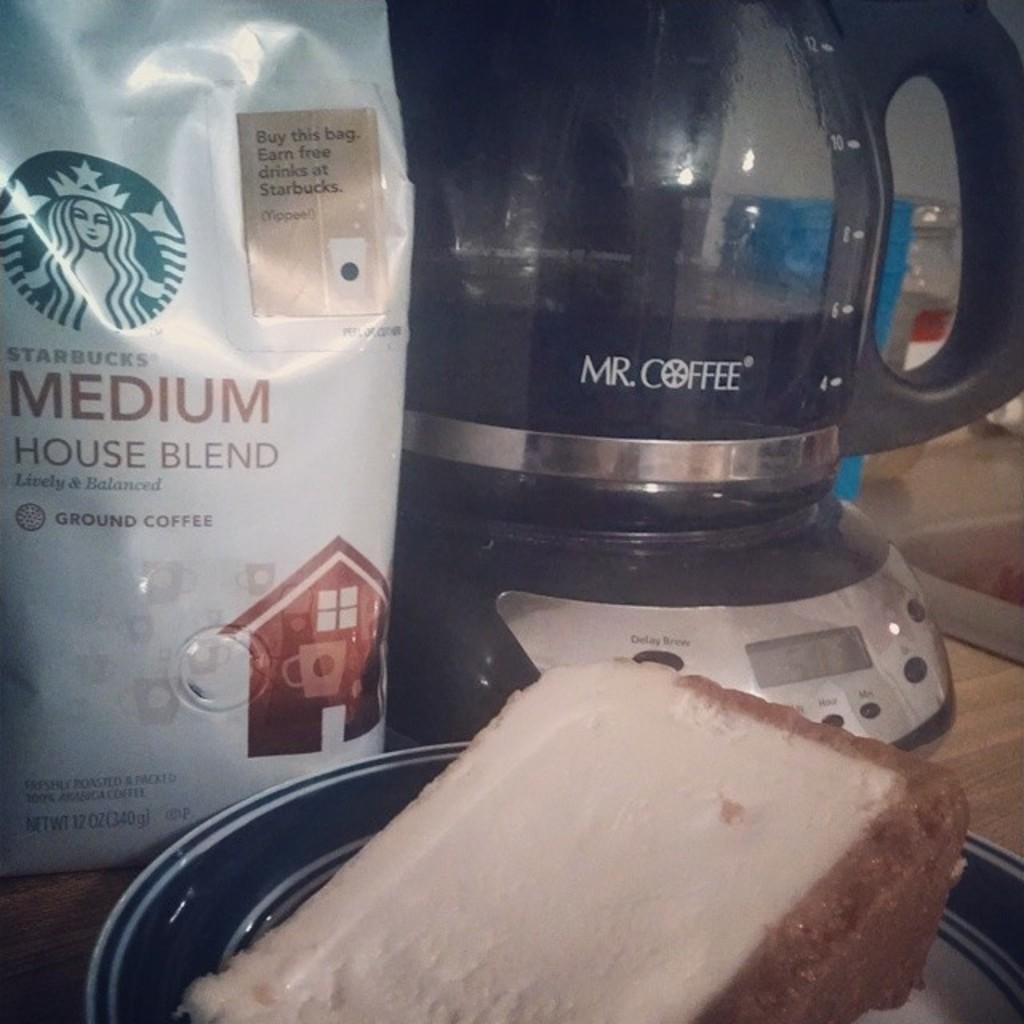What blend is the coffee?
Keep it short and to the point. Medium house blend. What is the brand of the coffee machine?
Your answer should be compact. Mr. coffee. 